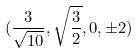<formula> <loc_0><loc_0><loc_500><loc_500>( \frac { 3 } { \sqrt { 1 0 } } , \sqrt { \frac { 3 } { 2 } } , 0 , \pm 2 )</formula> 